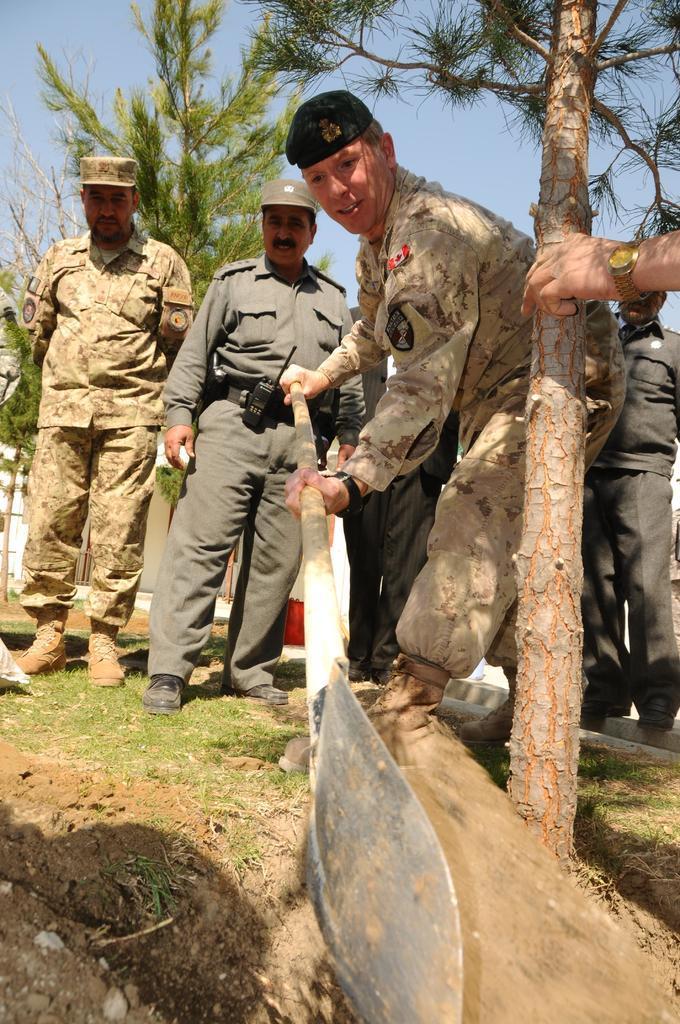Describe this image in one or two sentences. In this picture there is a soldier digging the ground with Shovel. Beside we can see a policeman standing and watching him. In the background there are some trees and in the front small tree trunk. 